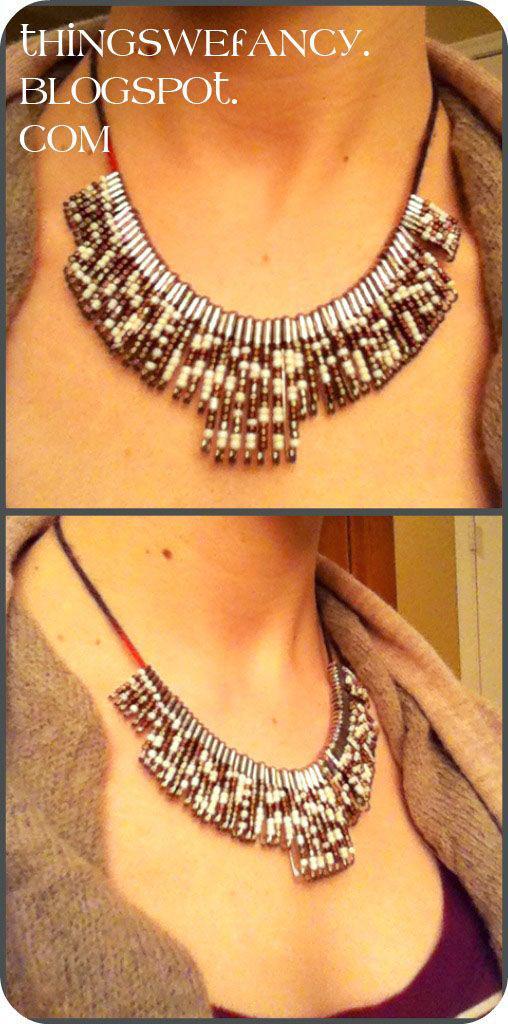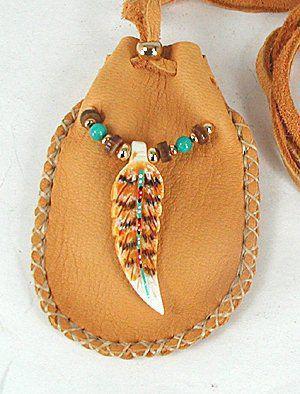The first image is the image on the left, the second image is the image on the right. Considering the images on both sides, is "One picture features jewelry made from safety pins that is meant to be worn around one's wrist." valid? Answer yes or no. No. The first image is the image on the left, the second image is the image on the right. Examine the images to the left and right. Is the description "An image shows a bracelet made of one color of safety pins, strung with beads." accurate? Answer yes or no. No. 